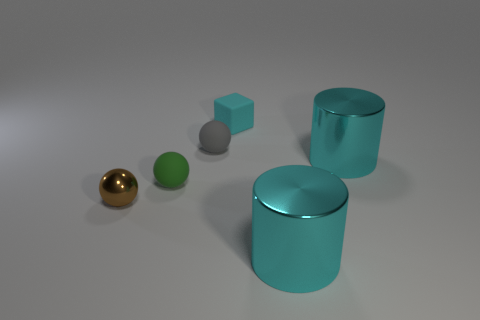Are there fewer tiny shiny cylinders than tiny shiny things?
Give a very brief answer. Yes. What number of cylinders are the same material as the tiny green ball?
Your response must be concise. 0. There is a tiny cube that is made of the same material as the green sphere; what is its color?
Offer a terse response. Cyan. What is the shape of the tiny gray object?
Ensure brevity in your answer.  Sphere. What number of large shiny cylinders are the same color as the small block?
Your answer should be compact. 2. There is a green thing that is the same size as the gray sphere; what is its shape?
Provide a succinct answer. Sphere. Is there a object that has the same size as the cyan block?
Your answer should be compact. Yes. There is a green ball that is the same size as the matte block; what material is it?
Your response must be concise. Rubber. There is a metal object that is right of the cyan metal thing in front of the small green thing; what is its size?
Make the answer very short. Large. There is a cyan cylinder that is behind the brown metallic ball; is its size the same as the tiny cyan matte thing?
Provide a short and direct response. No. 